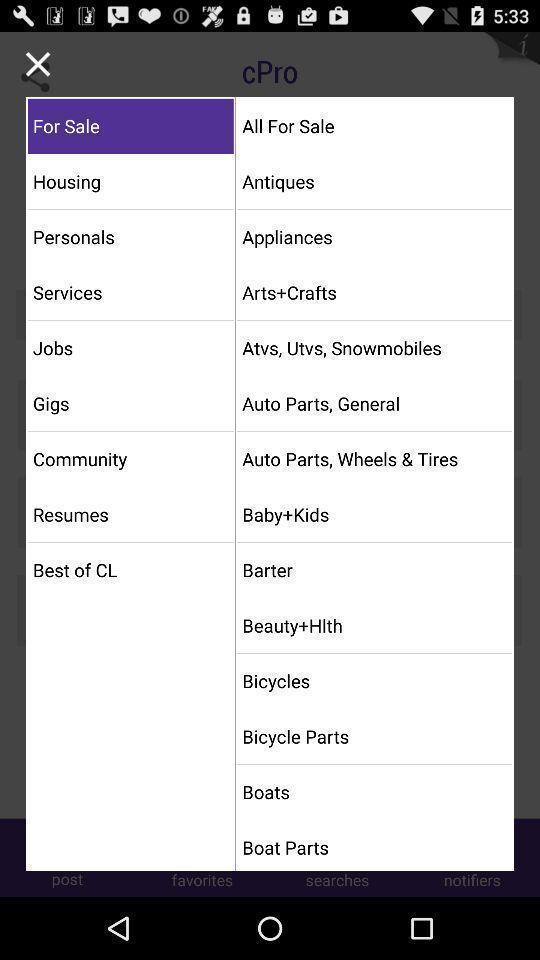Describe the key features of this screenshot. Pop-up displaying various filters. 